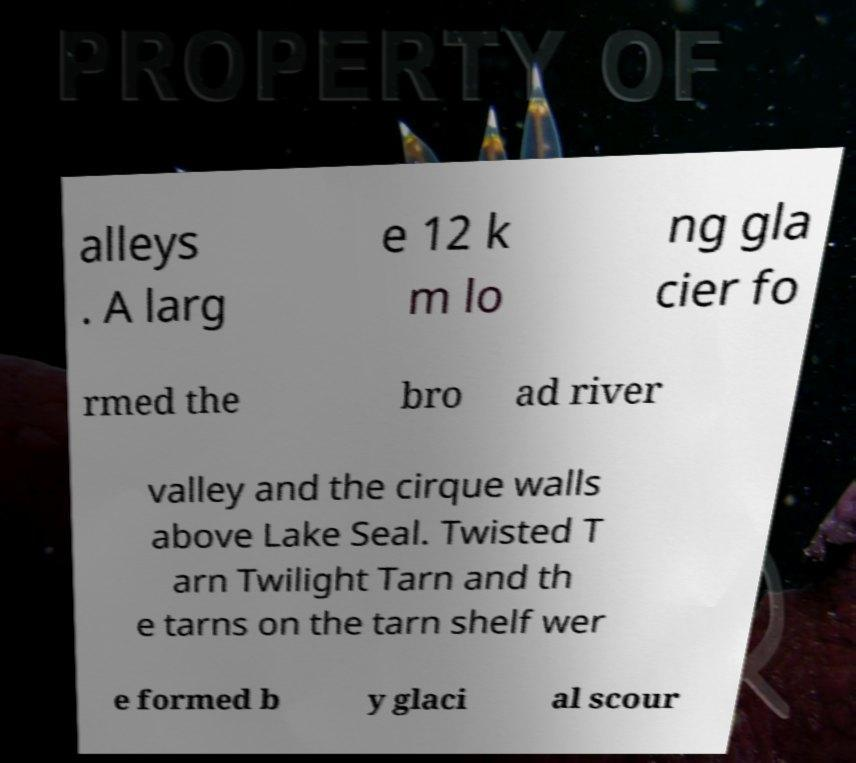There's text embedded in this image that I need extracted. Can you transcribe it verbatim? alleys . A larg e 12 k m lo ng gla cier fo rmed the bro ad river valley and the cirque walls above Lake Seal. Twisted T arn Twilight Tarn and th e tarns on the tarn shelf wer e formed b y glaci al scour 